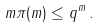<formula> <loc_0><loc_0><loc_500><loc_500>m \pi ( m ) \leq q ^ { m } \, .</formula> 